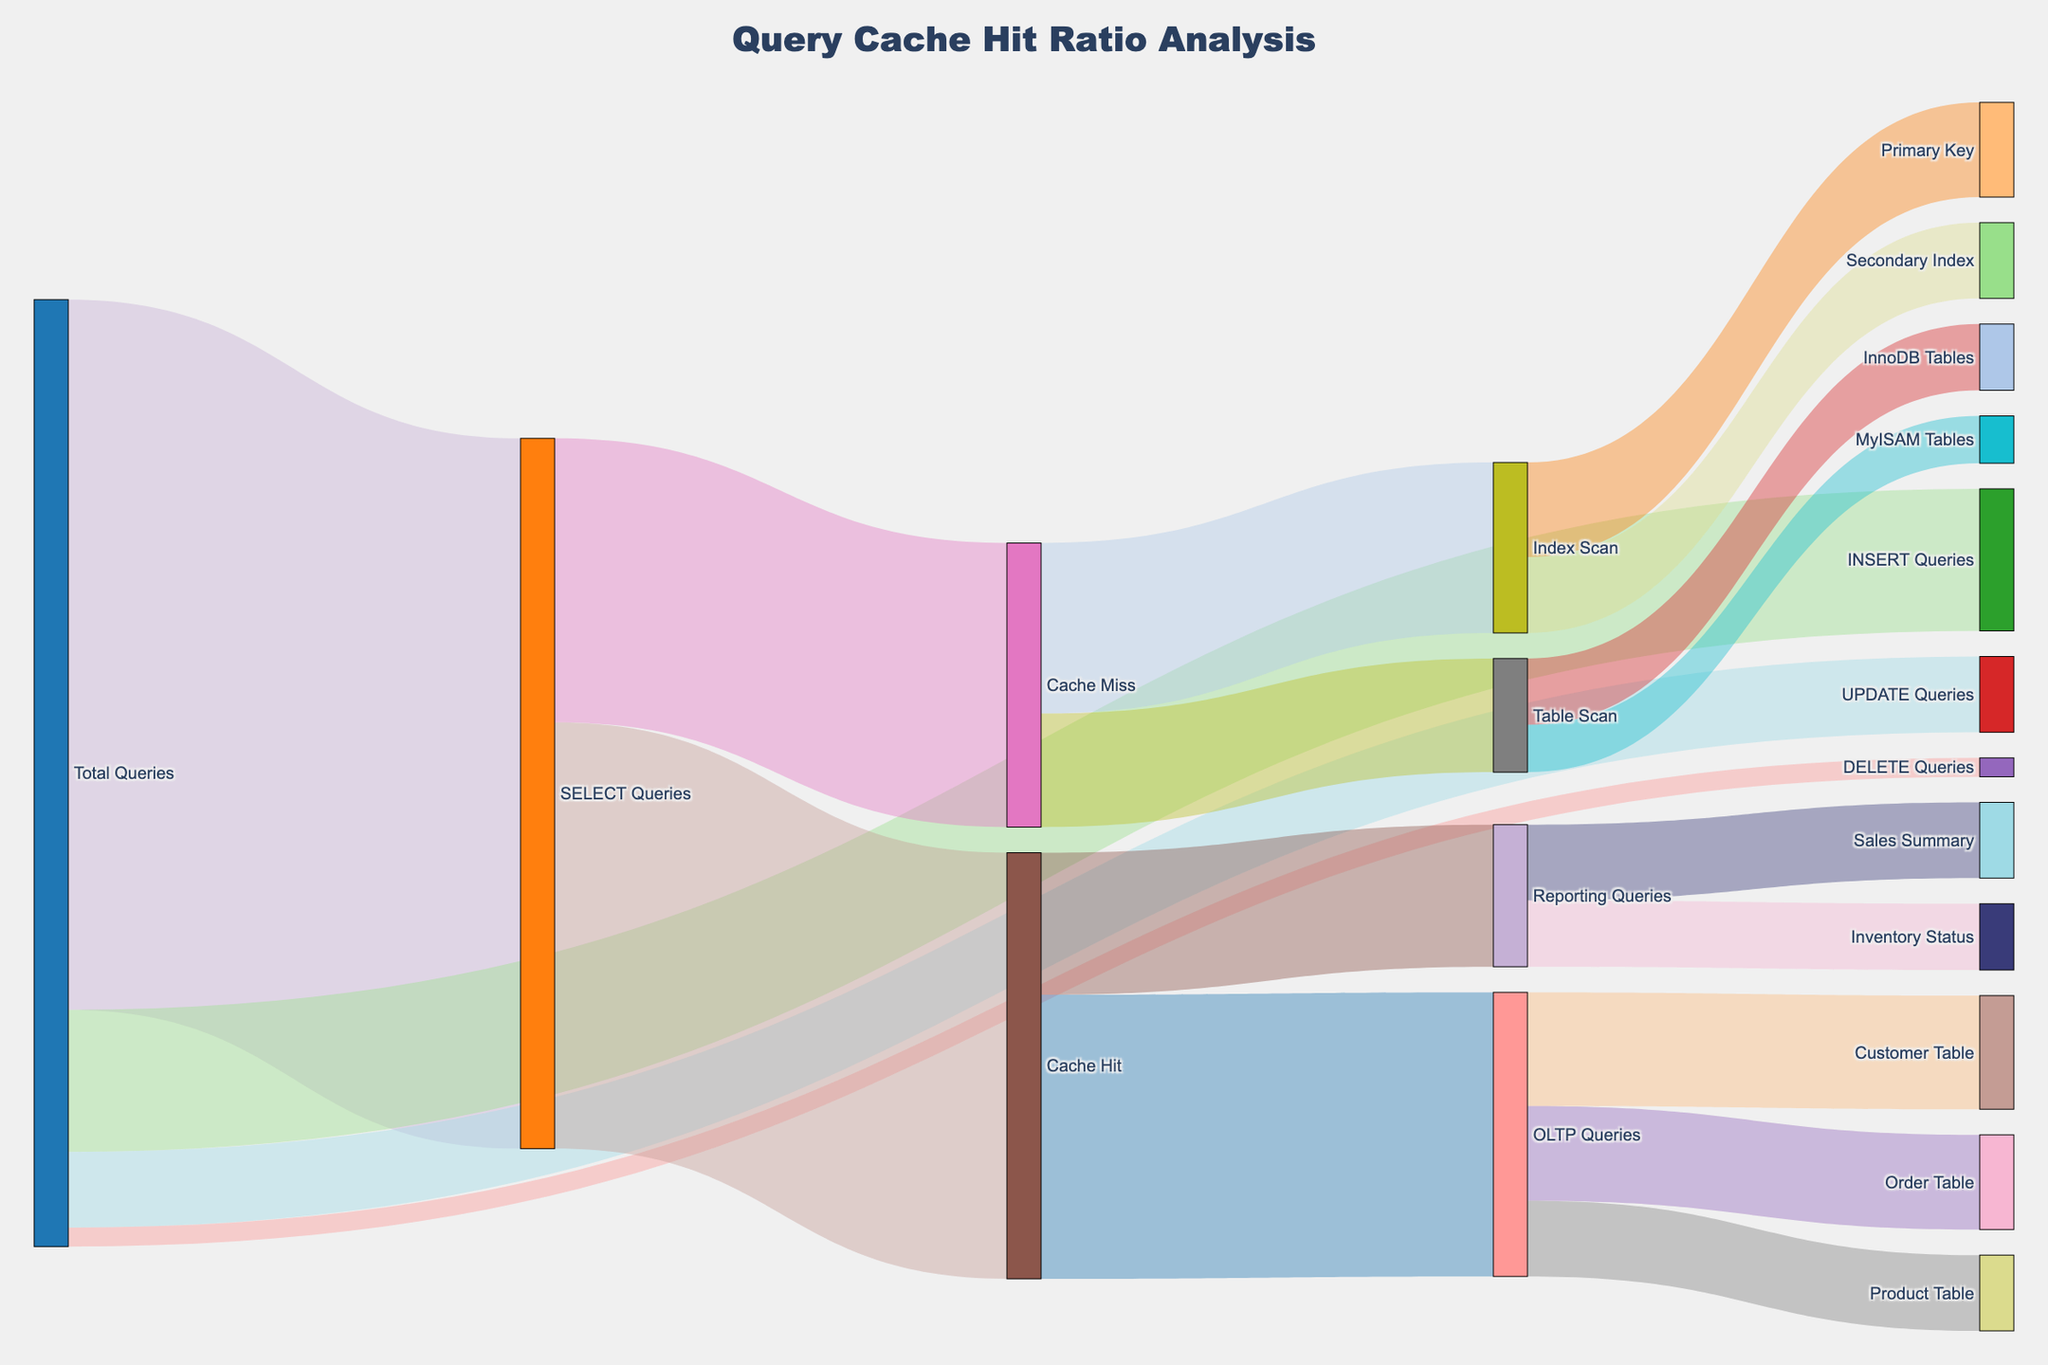What is the title of the Sankey diagram? The title of the Sankey diagram is usually displayed at the top of the figure. It summarizes the main topic of the analysis shown in the diagram.
Answer: Query Cache Hit Ratio Analysis How many total queries are shown in the Sankey diagram? The total queries can be identified as the cumulative value of all flows starting from the "Total Queries" node. Sum the values flowing to SELECT, INSERT, UPDATE, and DELETE Queries.
Answer: 100 Which type of query has the highest cache hit ratio? To determine the query type with the highest cache hit ratio, look at the width of the flow from "SELECT Queries" to "Cache Hit". This visual cue indicates the proportion of cache hits for each query type.
Answer: SELECT Queries What percentage of SELECT queries result in a cache miss? Calculate the percentage of SELECT queries resulting in a cache miss by dividing the value of "Cache Miss" (30) by the value of "SELECT Queries" (75) and then multiplying by 100.
Answer: 40% How many Reporting Queries result in a cache hit and what are their specific types? The number of Reporting Queries resulting in a cache hit is given directly by the flow value from "Cache Hit" to "Reporting Queries". Further divide into "Sales Summary" and "Inventory Status" to identify specific types.
Answer: 15 Reporting Queries (8 Sales Summary, 7 Inventory Status) Compare the number of table scans to the number of index scans. Which one is higher? To compare table scans and index scans, look at the flows from "Cache Miss" to "Table Scan" and "Index Scan". Sum the respective values.
Answer: Index scans (18) are higher than table scans (12) What is the total number of OLTP Queries that hit the cache? To find the total number of OLTP Queries hitting the cache, sum the values of flows from "Cache Hit" leading to specific OLTP Query types.
Answer: 30 OLTP Queries Break down the hits and misses for SELECT queries based on the table access patterns. For hits, look at the flow from "Cache Hit" to the respective OLTP and Reporting Queries. For misses, follow the flow to "Table Scan" and "Index Scan", and further to specific tables.
Answer: Cache Hit: 30 OLTP + 15 Reporting; Cache Miss: 12 Table Scan (5 MyISAM + 7 InnoDB) + 18 Index Scan (10 Primary Key + 8 Secondary Index) What is the proportion of MyISAM Tables to InnoDB Tables for table scans? To find the proportion, divide the value of table scans for MyISAM Tables by the value for InnoDB Tables. Simplify the fraction or convert it to a percentage.
Answer: 5:7 Determine the total number of queries that are hits in the cache for both OLTP and Reporting Queries. Sum the flows leading to "OLTP Queries" and "Reporting Queries" from "Cache Hit".
Answer: 45 Queries (30 OLTP + 15 Reporting) 